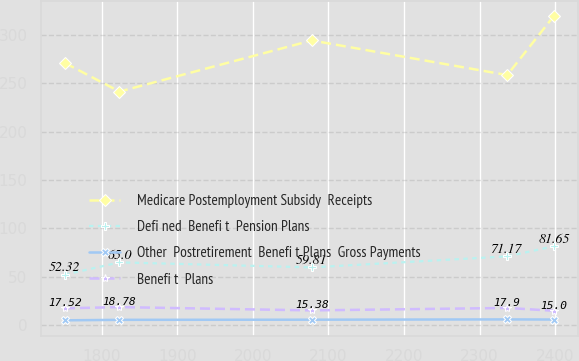Convert chart to OTSL. <chart><loc_0><loc_0><loc_500><loc_500><line_chart><ecel><fcel>Medicare Postemployment Subsidy  Receipts<fcel>Defi ned  Benefi t  Pension Plans<fcel>Other  Postretirement  Benefi t Plans  Gross Payments<fcel>Benefi t  Plans<nl><fcel>1751.63<fcel>270.95<fcel>52.32<fcel>5.13<fcel>17.52<nl><fcel>1823.69<fcel>241.44<fcel>65<fcel>5.62<fcel>18.78<nl><fcel>2078.06<fcel>294.29<fcel>59.81<fcel>5.77<fcel>15.38<nl><fcel>2336.53<fcel>258.49<fcel>71.17<fcel>6.07<fcel>17.9<nl><fcel>2398.41<fcel>319.71<fcel>81.65<fcel>5.93<fcel>15<nl></chart> 